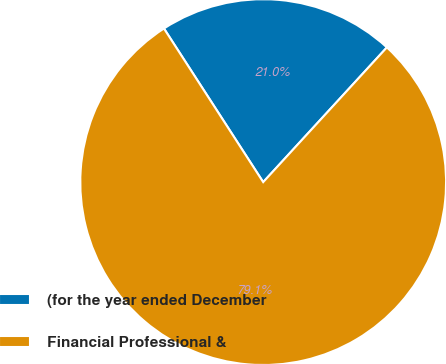Convert chart to OTSL. <chart><loc_0><loc_0><loc_500><loc_500><pie_chart><fcel>(for the year ended December<fcel>Financial Professional &<nl><fcel>20.95%<fcel>79.05%<nl></chart> 